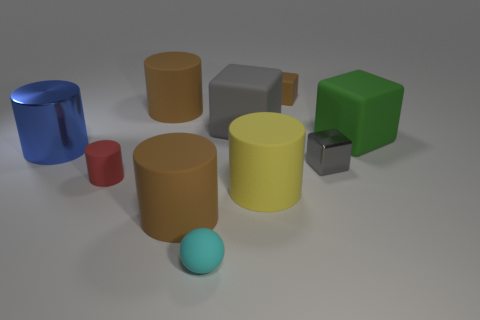What is the shape of the big object that is behind the rubber block on the left side of the small block that is behind the large shiny cylinder?
Keep it short and to the point. Cylinder. What number of objects are red matte cylinders or small gray cubes?
Your answer should be compact. 2. Does the brown matte thing that is in front of the big green rubber cube have the same shape as the thing that is to the left of the red matte cylinder?
Keep it short and to the point. Yes. How many objects are behind the red rubber thing and in front of the tiny matte cube?
Your answer should be very brief. 5. How many other objects are there of the same size as the red object?
Ensure brevity in your answer.  3. What is the material of the large cylinder that is in front of the green matte thing and behind the large yellow matte cylinder?
Your answer should be compact. Metal. Does the metallic block have the same color as the big cube that is left of the small gray metal object?
Offer a very short reply. Yes. What size is the brown object that is the same shape as the big gray thing?
Offer a terse response. Small. There is a big matte object that is both in front of the large metal object and on the right side of the tiny cyan rubber ball; what shape is it?
Your answer should be very brief. Cylinder. Do the blue metallic thing and the brown matte thing that is right of the tiny cyan matte sphere have the same size?
Ensure brevity in your answer.  No. 